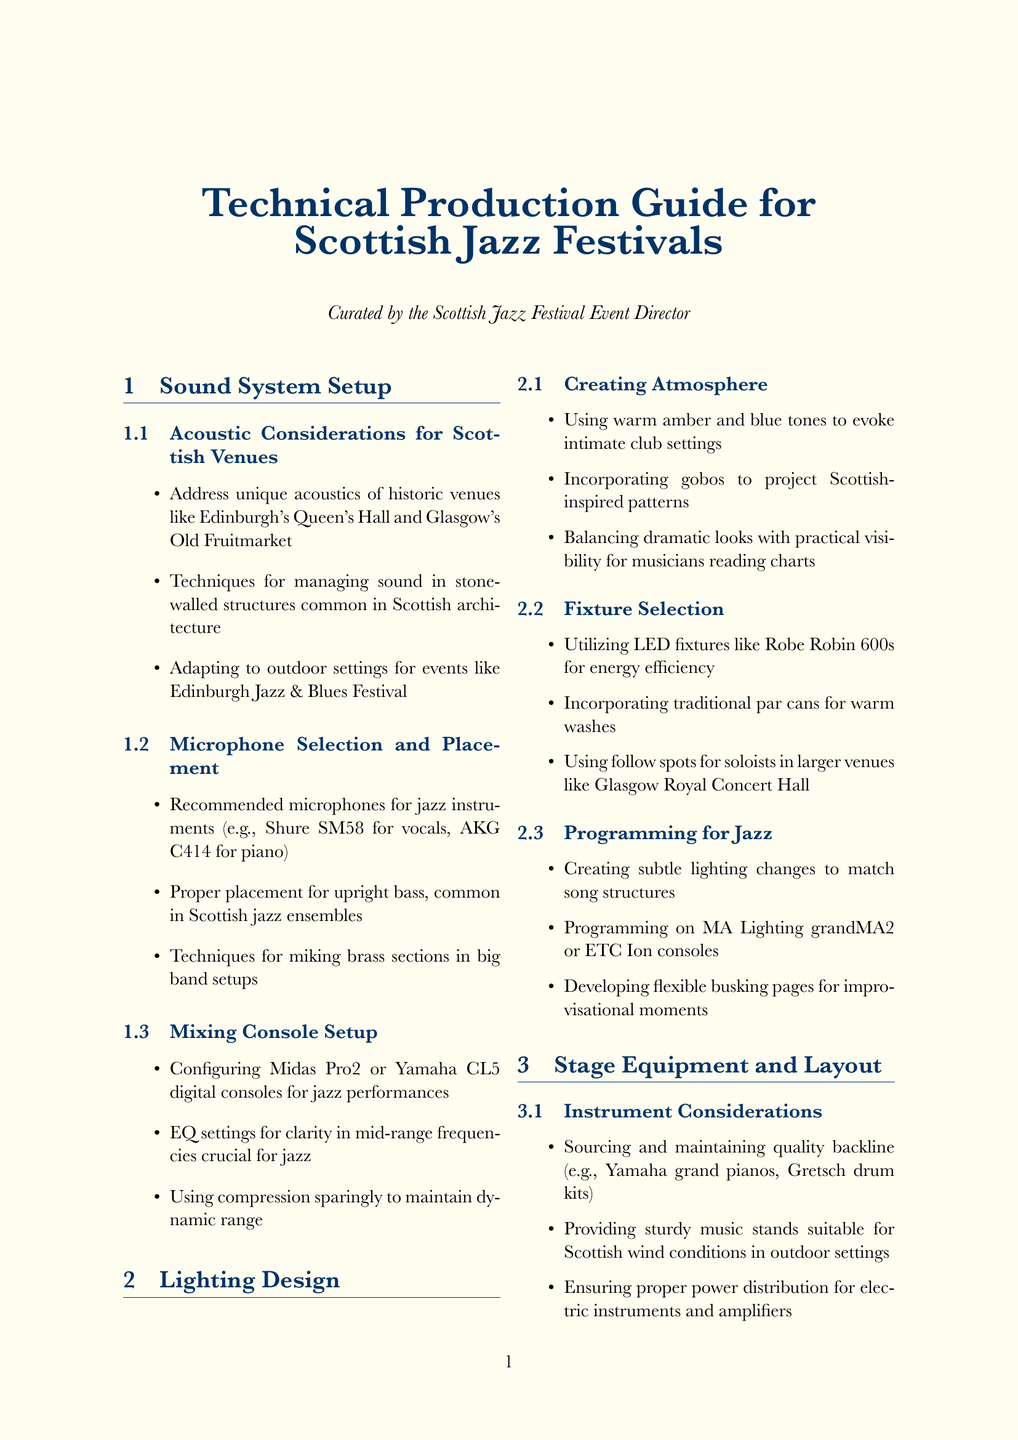what is the title of the manual? The title of the manual is provided at the beginning of the document.
Answer: Technical Production Guide for Scottish Jazz Festivals how many subsections are there under Sound System Setup? The number of subsections under Sound System Setup is listed in the table of contents.
Answer: 3 which microphone is recommended for vocals? The recommended microphone for vocals is mentioned in the subsection on Microphone Selection and Placement.
Answer: Shure SM58 which lighting console is suggested for programming? The subsection on Programming for Jazz specifies which console to use for programming.
Answer: MA Lighting grandMA2 what type of venue-specific consideration is discussed for outdoor festivals? The venue-specific considerations section outlines different types of venues, one of which is for outdoor festivals.
Answer: Weather-proofing equipment what kind of PPE is mentioned for load-in and rigging? The Personal Protective Equipment subsection includes specific examples of PPE needed during load-in and rigging.
Answer: Appropriate PPE what implications are there for working in historic venues? The considerations for historic venues notate specific limitations and requirements.
Answer: Working within limitations of listed buildings how are subtle lighting changes created? The Programming for Jazz section discusses how to create these changes in lighting during performances.
Answer: Creating subtle lighting changes to match song structures 